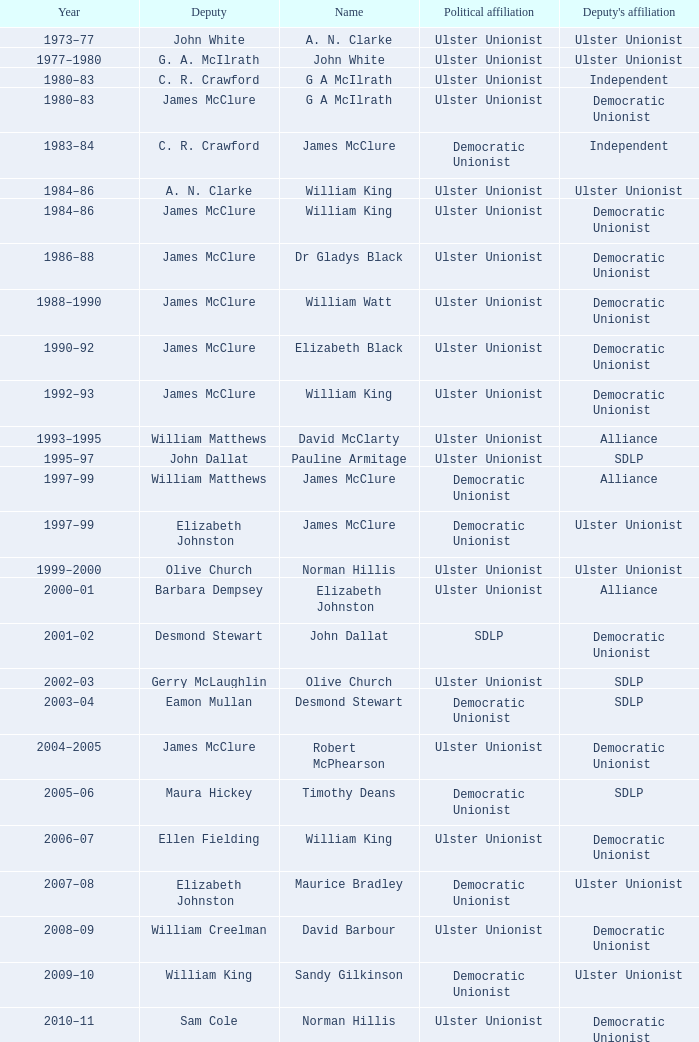What is the name of the Deputy when the Name was elizabeth black? James McClure. 